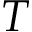<formula> <loc_0><loc_0><loc_500><loc_500>T</formula> 